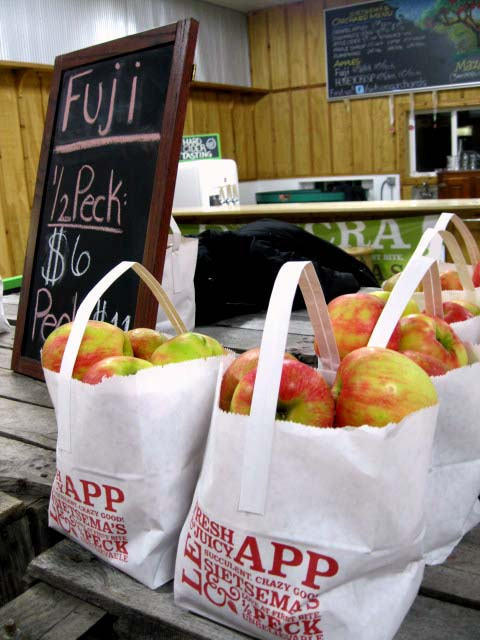<image>What is written on the chalkboard? I don't know exactly what is written on the chalkboard. It might be 'fuji', 'fuji 1 2 peck $6', '1 2 peck: $6' or 'apple prices'. What is written on the chalkboard? I am not sure what is written on the chalkboard. It can be seen 'fuji', 'fuji 1 2 peck $6', 'apple prices' or '1 2 peck: $6'. 